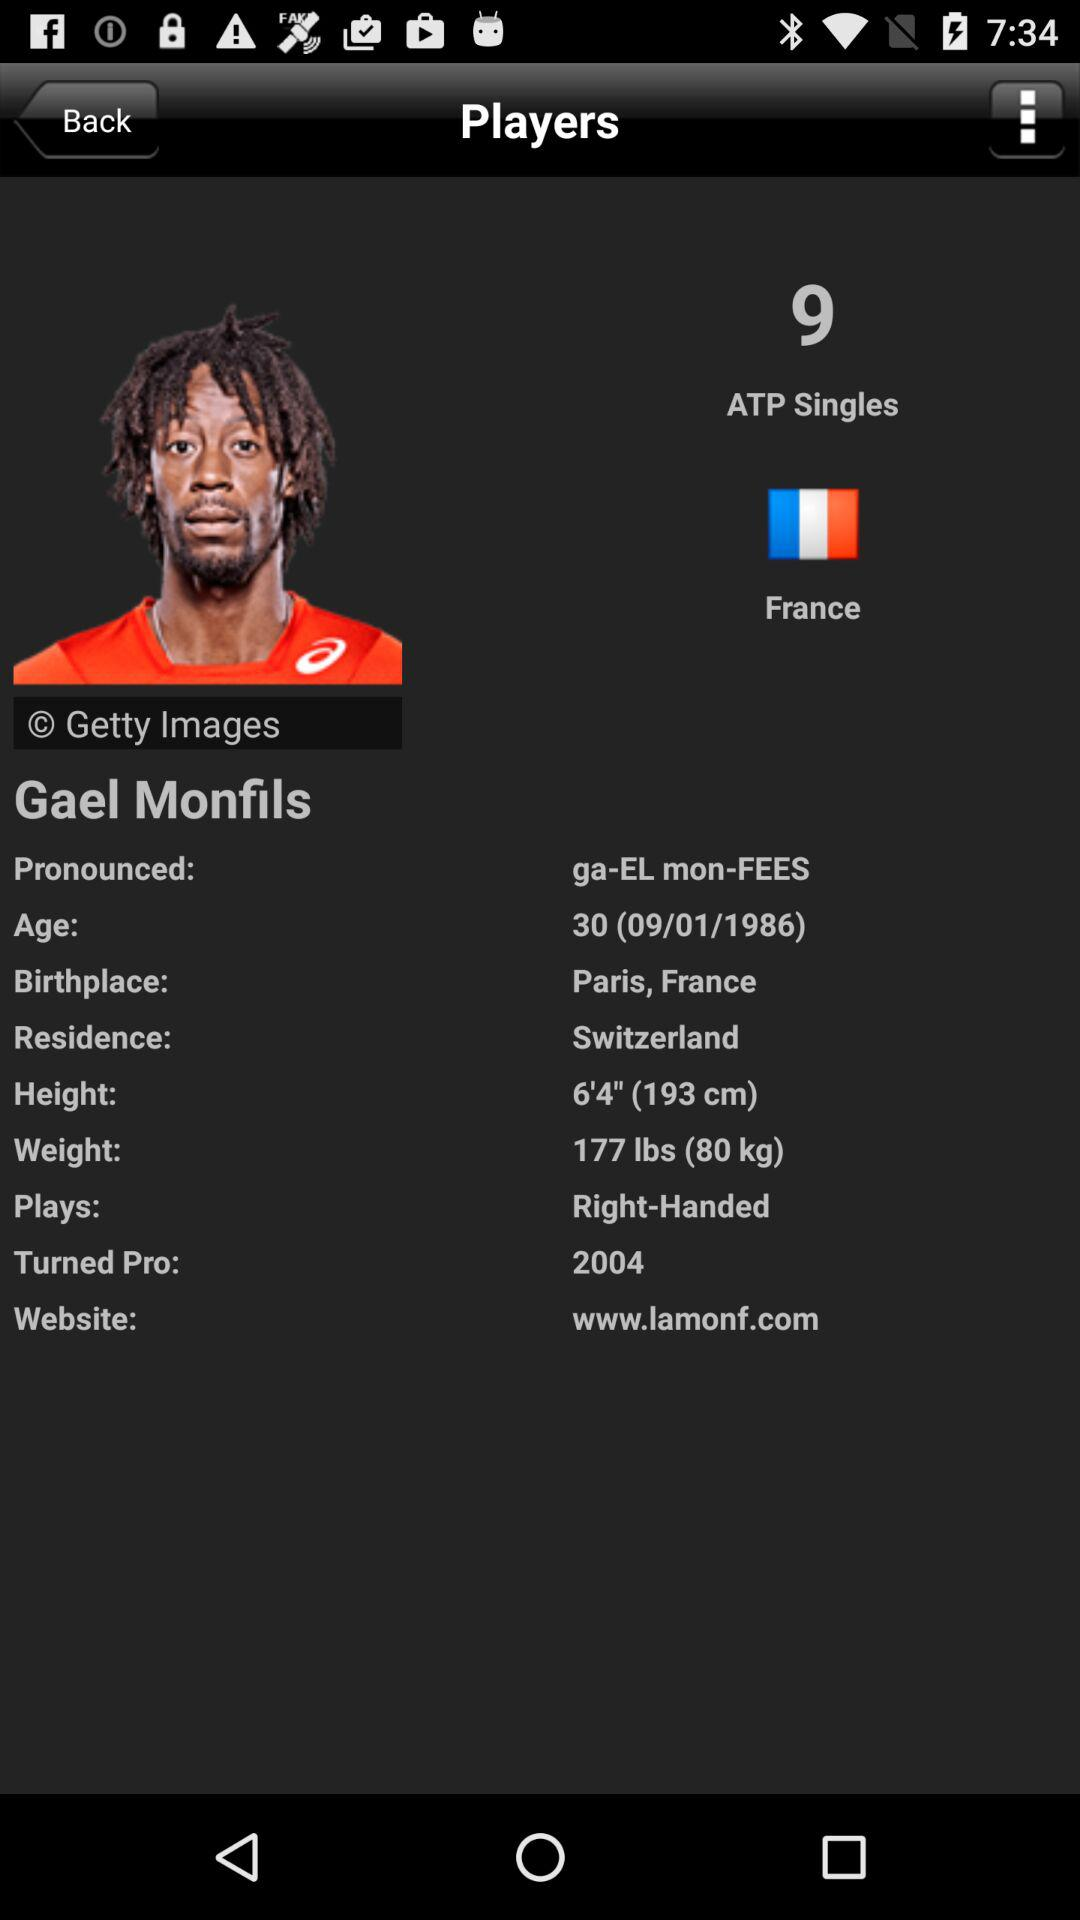What is the weight of the player? The weight of the player is 177 lbs (80 kg). 